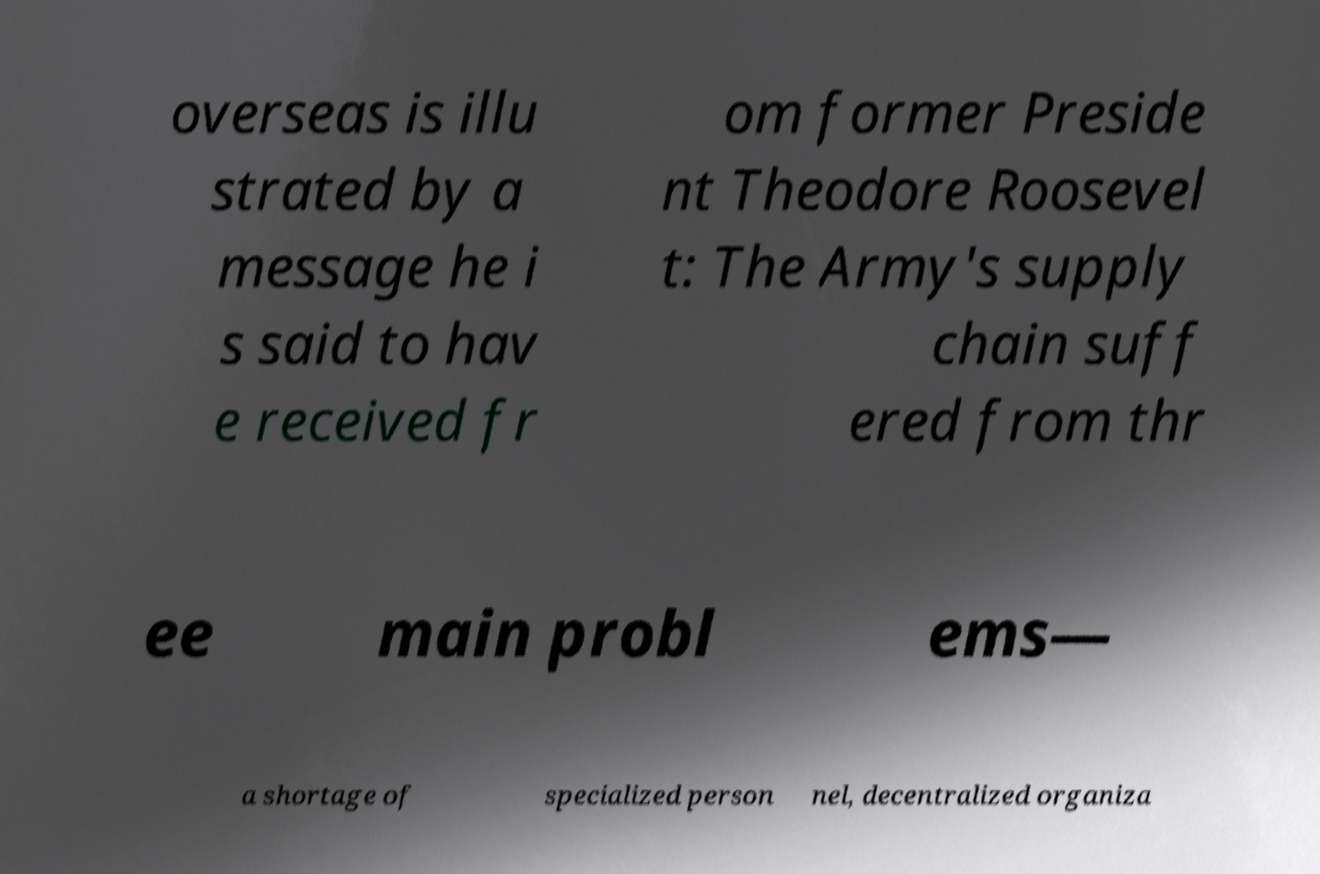Please identify and transcribe the text found in this image. overseas is illu strated by a message he i s said to hav e received fr om former Preside nt Theodore Roosevel t: The Army's supply chain suff ered from thr ee main probl ems— a shortage of specialized person nel, decentralized organiza 